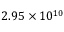Convert formula to latex. <formula><loc_0><loc_0><loc_500><loc_500>2 . 9 5 \times 1 0 ^ { 1 0 }</formula> 